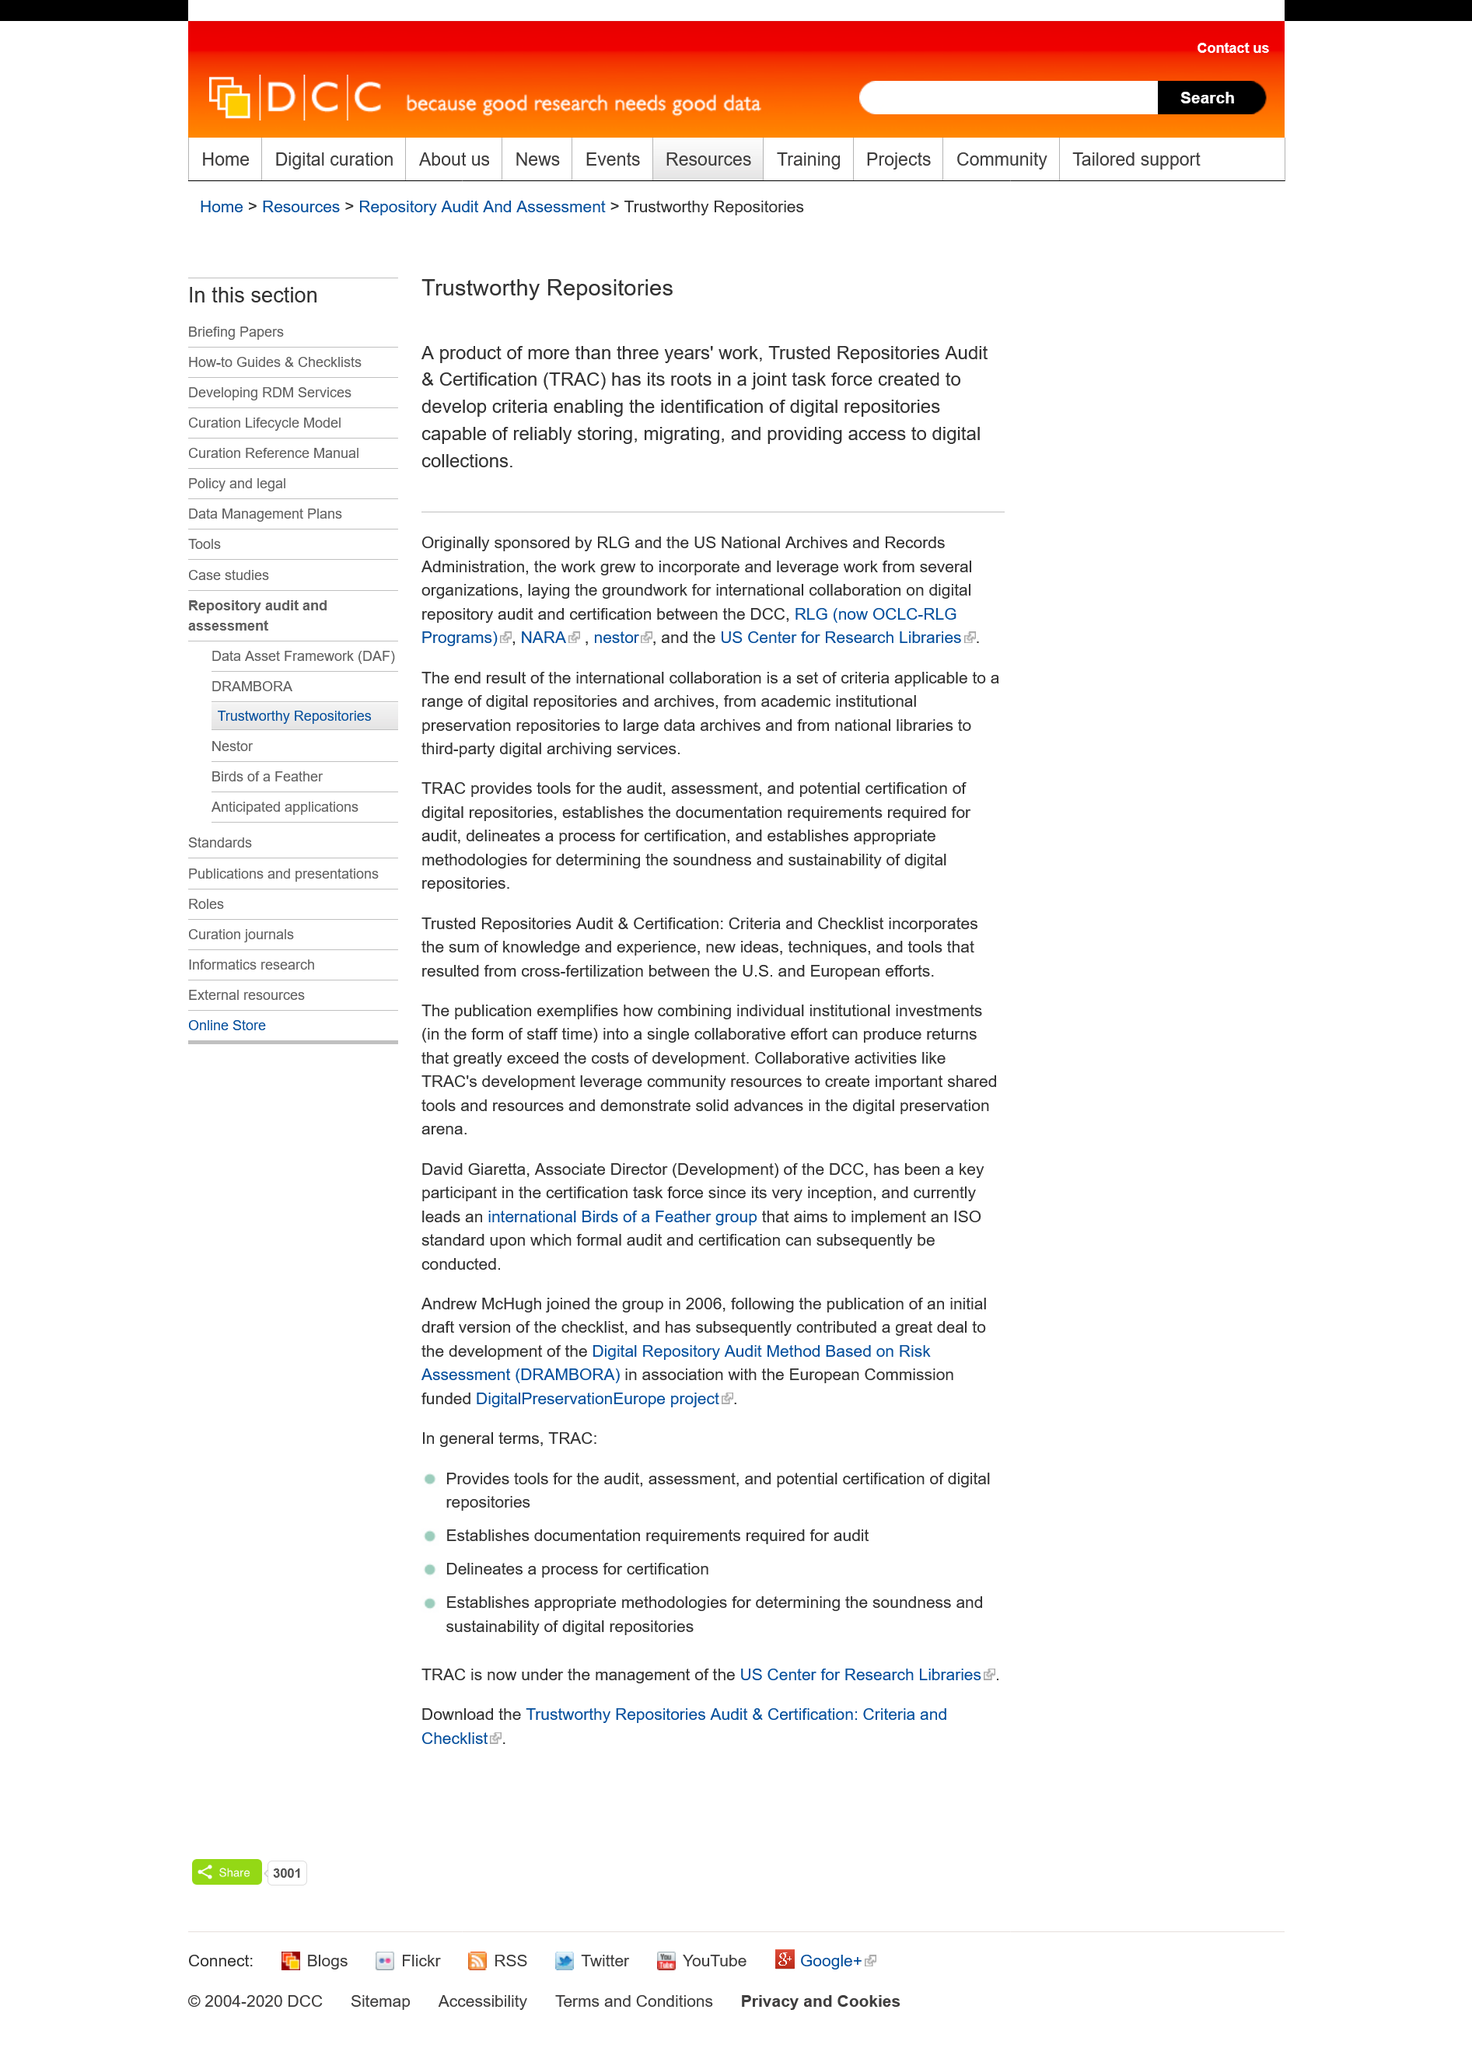Highlight a few significant elements in this photo. Yes, digital collections are available through the Trusted Repositories Audit. The Trusted Repositories Audit & Certification, also known as TRAC, is commonly referred to as The Trusted Repositories Audit & Certification. The Trusted Repositories Audit and Certification was initially supported by RLG and the US National and Records Administration. 